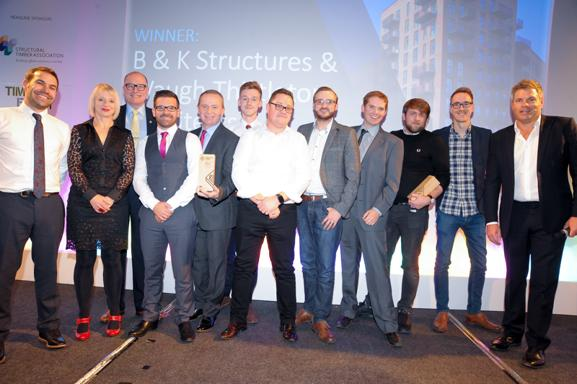What is the significance of the trophy one of the individuals is holding? The trophy indicates that the group has likely won an award, which judging by the text on the backdrop, might be associated with innovation or achievements in structural engineering or a related industry. This kind of recognition often highlights significant contributions or milestones achieved by the individuals or their company. Can you describe the attire of the people in the image? Most individuals in the image are dressed in smart formal wear, predominantly suits for men and a dress for the woman. The prevalent use of dark colors like black and navy aligns with typical corporate or formal event attire, appropriate for an awards ceremony setting. 